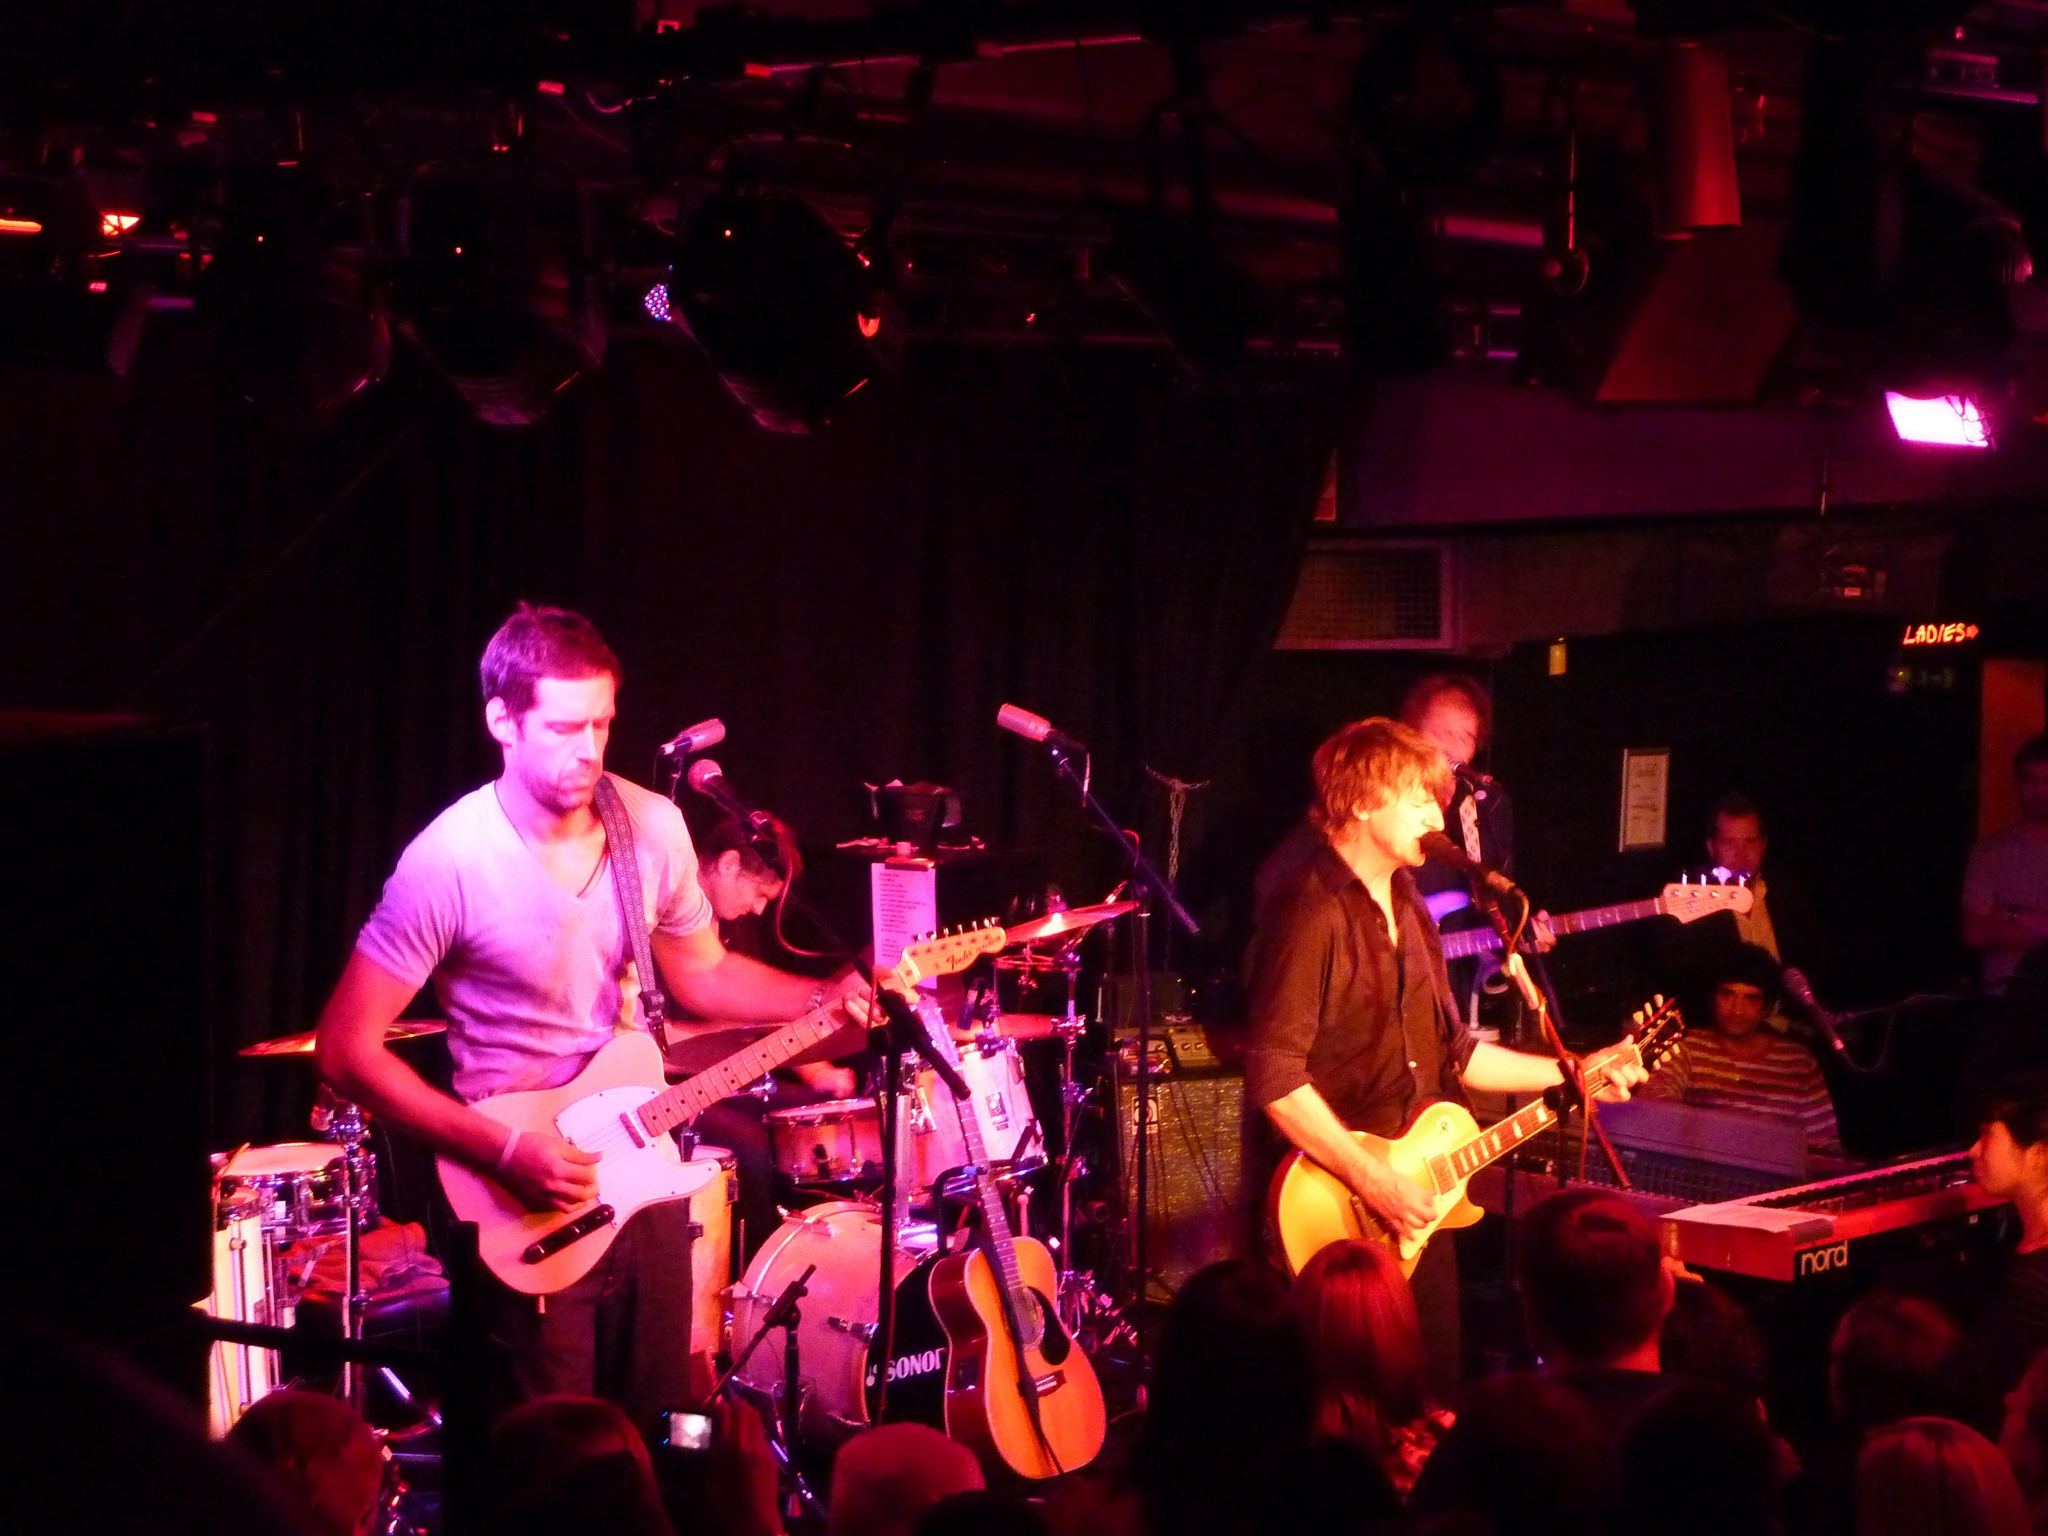What are the musicians in the image doing? The musicians in the image are playing music with guitars and other musical instruments. What can be seen on the musicians in the image? There is a lot of lighting on the musicians. What is visible in the background of the image? There is a dark cloth in the background of the image. Can you see a quilt being used as a stage prop in the image? There is no quilt present in the image. Are there any turkeys visible in the image? There are no turkeys visible in the image. 